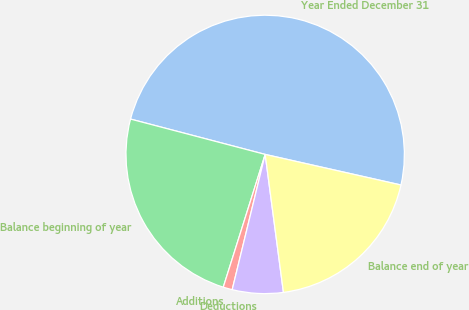Convert chart to OTSL. <chart><loc_0><loc_0><loc_500><loc_500><pie_chart><fcel>Year Ended December 31<fcel>Balance beginning of year<fcel>Additions<fcel>Deductions<fcel>Balance end of year<nl><fcel>49.44%<fcel>24.22%<fcel>1.06%<fcel>5.9%<fcel>19.38%<nl></chart> 